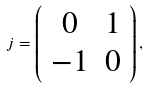<formula> <loc_0><loc_0><loc_500><loc_500>j = \left ( \begin{array} { c c } 0 & 1 \\ - 1 & 0 \end{array} \right ) ,</formula> 